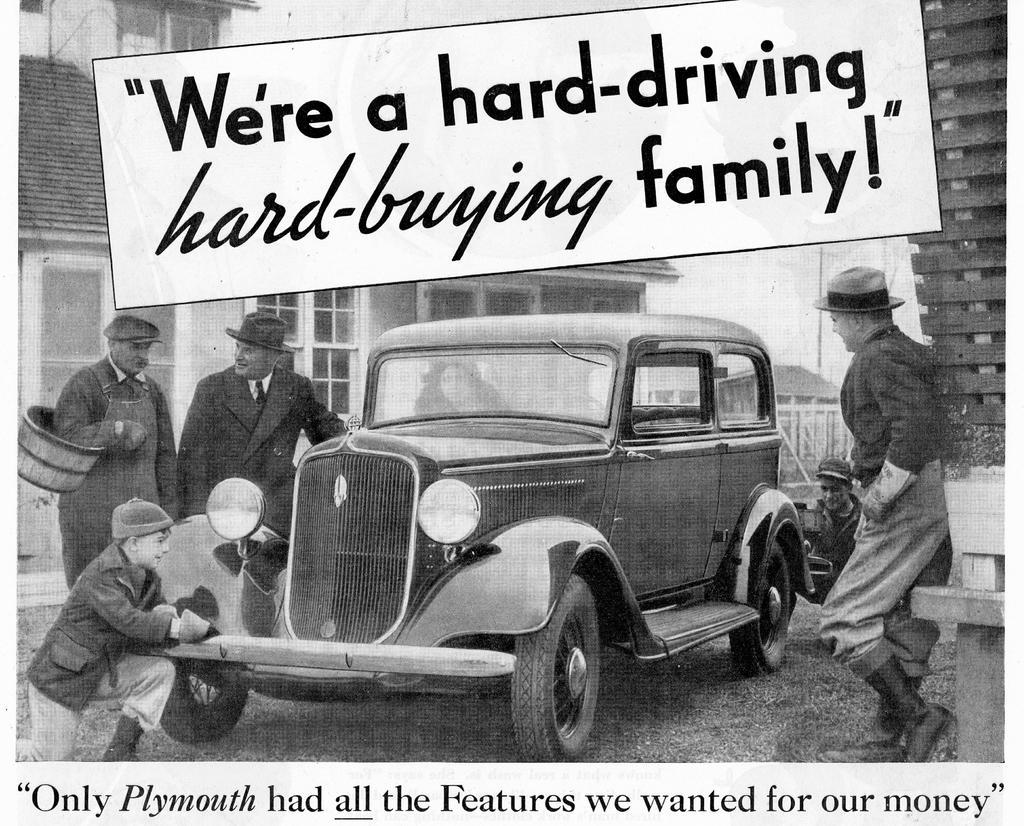Can you describe this image briefly? This is a black and white poster. This poster is titled as "We're a hard-driving hard-buying family!". In this poster a car is highlighted. Beside this car 4 persons are standing. This persons wore a hat. There are number of buildings with windows and doors. This person is holding a basket. 